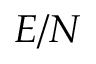Convert formula to latex. <formula><loc_0><loc_0><loc_500><loc_500>E / N</formula> 